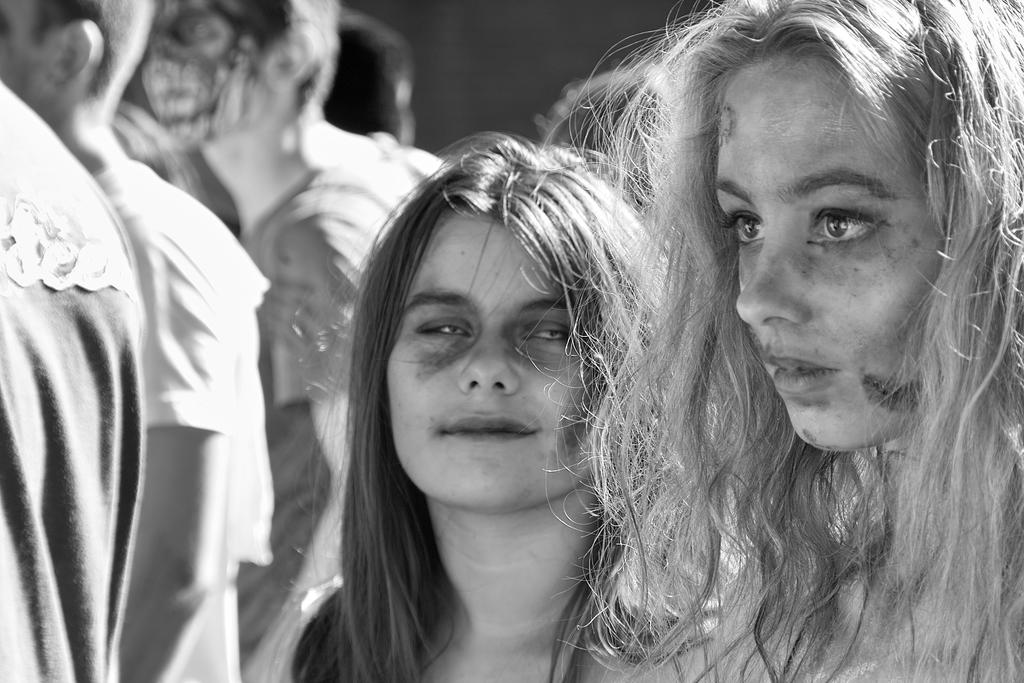What is the color scheme of the picture? The picture is black and white. What can be seen in the picture? There are people in the picture. What type of sound can be heard coming from the seashore in the image? There is no seashore present in the image, and therefore no sound can be heard from it. 